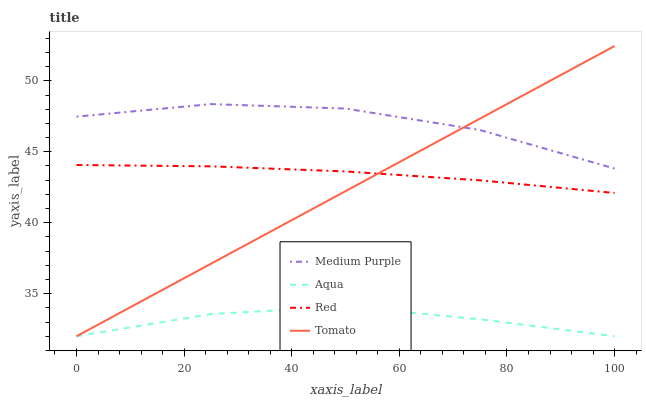Does Aqua have the minimum area under the curve?
Answer yes or no. Yes. Does Medium Purple have the maximum area under the curve?
Answer yes or no. Yes. Does Tomato have the minimum area under the curve?
Answer yes or no. No. Does Tomato have the maximum area under the curve?
Answer yes or no. No. Is Tomato the smoothest?
Answer yes or no. Yes. Is Medium Purple the roughest?
Answer yes or no. Yes. Is Aqua the smoothest?
Answer yes or no. No. Is Aqua the roughest?
Answer yes or no. No. Does Tomato have the lowest value?
Answer yes or no. Yes. Does Red have the lowest value?
Answer yes or no. No. Does Tomato have the highest value?
Answer yes or no. Yes. Does Aqua have the highest value?
Answer yes or no. No. Is Aqua less than Medium Purple?
Answer yes or no. Yes. Is Medium Purple greater than Aqua?
Answer yes or no. Yes. Does Aqua intersect Tomato?
Answer yes or no. Yes. Is Aqua less than Tomato?
Answer yes or no. No. Is Aqua greater than Tomato?
Answer yes or no. No. Does Aqua intersect Medium Purple?
Answer yes or no. No. 